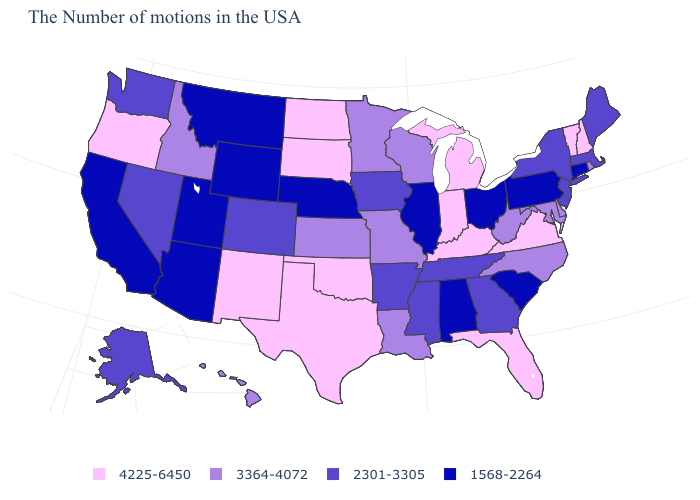Among the states that border Arizona , which have the highest value?
Give a very brief answer. New Mexico. What is the value of South Carolina?
Quick response, please. 1568-2264. Which states have the lowest value in the West?
Be succinct. Wyoming, Utah, Montana, Arizona, California. What is the lowest value in the USA?
Answer briefly. 1568-2264. Which states hav the highest value in the South?
Give a very brief answer. Virginia, Florida, Kentucky, Oklahoma, Texas. Does West Virginia have the lowest value in the USA?
Keep it brief. No. What is the lowest value in the USA?
Concise answer only. 1568-2264. Among the states that border Massachusetts , does New Hampshire have the lowest value?
Write a very short answer. No. Name the states that have a value in the range 3364-4072?
Write a very short answer. Rhode Island, Delaware, Maryland, North Carolina, West Virginia, Wisconsin, Louisiana, Missouri, Minnesota, Kansas, Idaho, Hawaii. What is the value of Kentucky?
Short answer required. 4225-6450. Name the states that have a value in the range 1568-2264?
Concise answer only. Connecticut, Pennsylvania, South Carolina, Ohio, Alabama, Illinois, Nebraska, Wyoming, Utah, Montana, Arizona, California. What is the value of Wisconsin?
Keep it brief. 3364-4072. What is the value of Kansas?
Answer briefly. 3364-4072. Does Iowa have a higher value than South Carolina?
Short answer required. Yes. Does Maine have a lower value than Virginia?
Be succinct. Yes. 